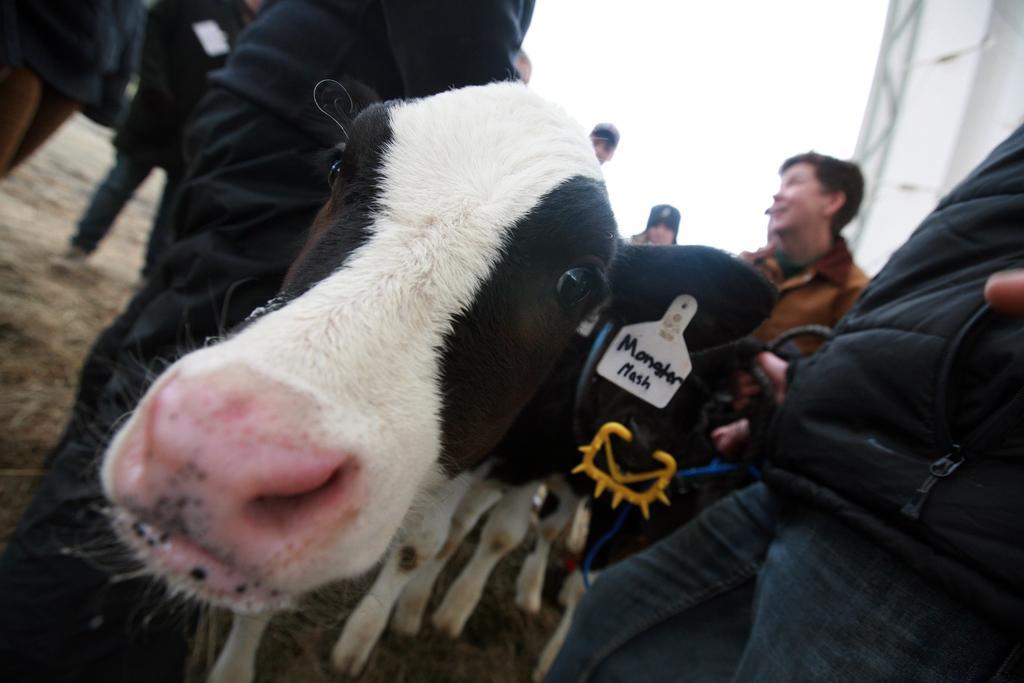Could you give a brief overview of what you see in this image? In this image we can see animals and few people, some written text, we can see the sky in the background. 